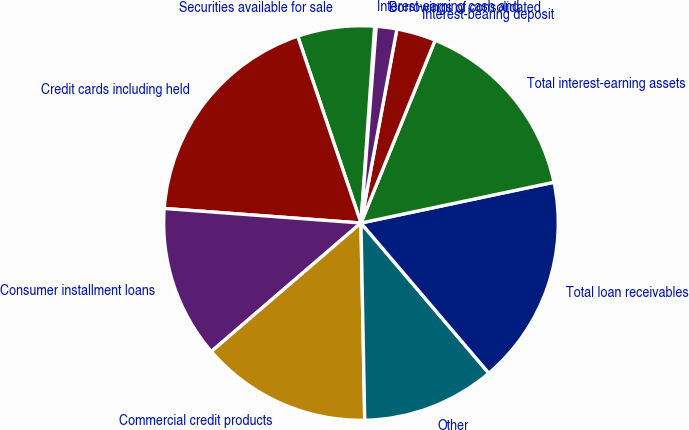<chart> <loc_0><loc_0><loc_500><loc_500><pie_chart><fcel>Interest-earning cash and<fcel>Securities available for sale<fcel>Credit cards including held<fcel>Consumer installment loans<fcel>Commercial credit products<fcel>Other<fcel>Total loan receivables<fcel>Total interest-earning assets<fcel>Interest-bearing deposit<fcel>Borrowings of consolidated<nl><fcel>0.13%<fcel>6.3%<fcel>18.63%<fcel>12.47%<fcel>14.01%<fcel>10.92%<fcel>17.09%<fcel>15.55%<fcel>3.22%<fcel>1.68%<nl></chart> 